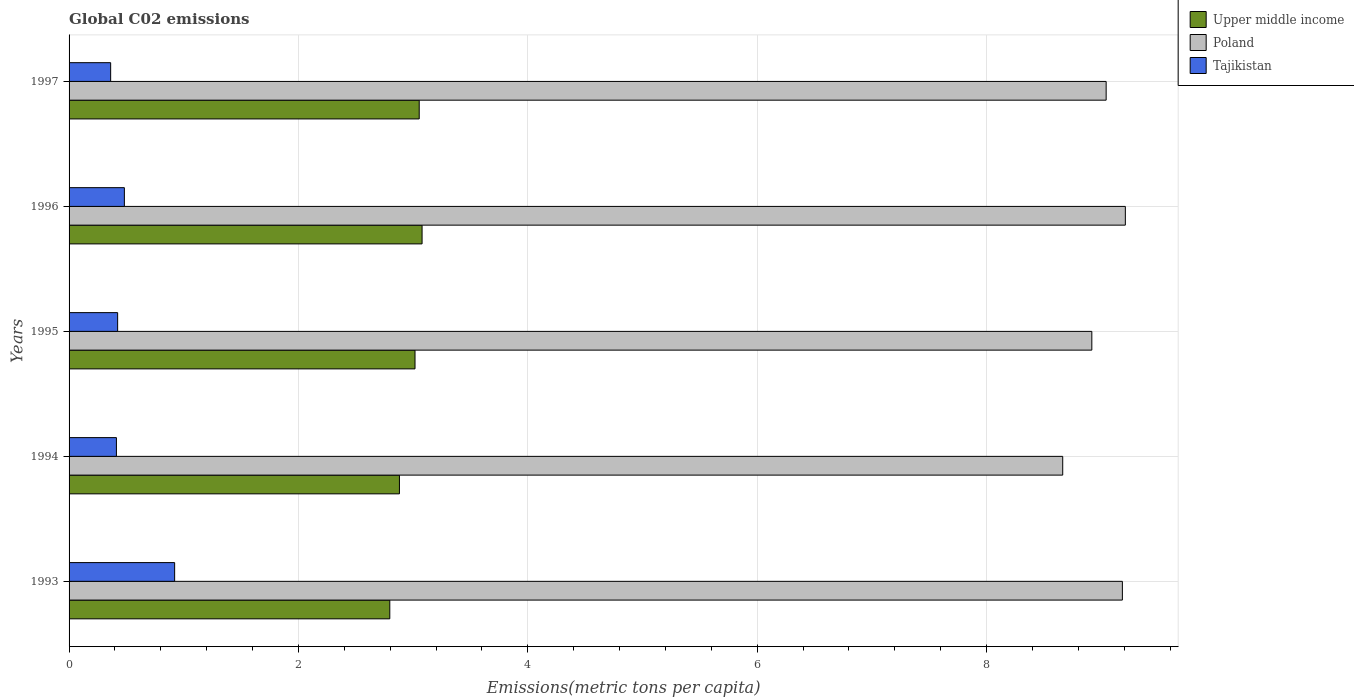How many different coloured bars are there?
Offer a very short reply. 3. Are the number of bars on each tick of the Y-axis equal?
Your response must be concise. Yes. How many bars are there on the 3rd tick from the top?
Your answer should be compact. 3. How many bars are there on the 4th tick from the bottom?
Offer a terse response. 3. In how many cases, is the number of bars for a given year not equal to the number of legend labels?
Your response must be concise. 0. What is the amount of CO2 emitted in in Poland in 1993?
Offer a terse response. 9.18. Across all years, what is the maximum amount of CO2 emitted in in Upper middle income?
Make the answer very short. 3.08. Across all years, what is the minimum amount of CO2 emitted in in Poland?
Offer a very short reply. 8.66. In which year was the amount of CO2 emitted in in Poland minimum?
Offer a very short reply. 1994. What is the total amount of CO2 emitted in in Poland in the graph?
Your answer should be compact. 45.02. What is the difference between the amount of CO2 emitted in in Tajikistan in 1993 and that in 1996?
Keep it short and to the point. 0.44. What is the difference between the amount of CO2 emitted in in Upper middle income in 1993 and the amount of CO2 emitted in in Tajikistan in 1994?
Ensure brevity in your answer.  2.38. What is the average amount of CO2 emitted in in Poland per year?
Keep it short and to the point. 9. In the year 1997, what is the difference between the amount of CO2 emitted in in Upper middle income and amount of CO2 emitted in in Tajikistan?
Provide a short and direct response. 2.69. What is the ratio of the amount of CO2 emitted in in Tajikistan in 1993 to that in 1994?
Provide a succinct answer. 2.23. Is the amount of CO2 emitted in in Poland in 1994 less than that in 1995?
Keep it short and to the point. Yes. Is the difference between the amount of CO2 emitted in in Upper middle income in 1995 and 1997 greater than the difference between the amount of CO2 emitted in in Tajikistan in 1995 and 1997?
Ensure brevity in your answer.  No. What is the difference between the highest and the second highest amount of CO2 emitted in in Upper middle income?
Provide a succinct answer. 0.03. What is the difference between the highest and the lowest amount of CO2 emitted in in Tajikistan?
Offer a terse response. 0.56. How many bars are there?
Provide a succinct answer. 15. What is the difference between two consecutive major ticks on the X-axis?
Keep it short and to the point. 2. Does the graph contain grids?
Keep it short and to the point. Yes. How are the legend labels stacked?
Your response must be concise. Vertical. What is the title of the graph?
Your answer should be compact. Global C02 emissions. Does "Eritrea" appear as one of the legend labels in the graph?
Provide a succinct answer. No. What is the label or title of the X-axis?
Give a very brief answer. Emissions(metric tons per capita). What is the Emissions(metric tons per capita) of Upper middle income in 1993?
Provide a short and direct response. 2.8. What is the Emissions(metric tons per capita) in Poland in 1993?
Offer a terse response. 9.18. What is the Emissions(metric tons per capita) in Tajikistan in 1993?
Ensure brevity in your answer.  0.92. What is the Emissions(metric tons per capita) of Upper middle income in 1994?
Provide a succinct answer. 2.88. What is the Emissions(metric tons per capita) of Poland in 1994?
Keep it short and to the point. 8.66. What is the Emissions(metric tons per capita) in Tajikistan in 1994?
Give a very brief answer. 0.41. What is the Emissions(metric tons per capita) in Upper middle income in 1995?
Your answer should be very brief. 3.02. What is the Emissions(metric tons per capita) of Poland in 1995?
Make the answer very short. 8.92. What is the Emissions(metric tons per capita) of Tajikistan in 1995?
Make the answer very short. 0.42. What is the Emissions(metric tons per capita) in Upper middle income in 1996?
Provide a succinct answer. 3.08. What is the Emissions(metric tons per capita) of Poland in 1996?
Offer a very short reply. 9.21. What is the Emissions(metric tons per capita) of Tajikistan in 1996?
Your answer should be compact. 0.48. What is the Emissions(metric tons per capita) of Upper middle income in 1997?
Provide a short and direct response. 3.05. What is the Emissions(metric tons per capita) in Poland in 1997?
Make the answer very short. 9.04. What is the Emissions(metric tons per capita) of Tajikistan in 1997?
Your answer should be compact. 0.36. Across all years, what is the maximum Emissions(metric tons per capita) of Upper middle income?
Keep it short and to the point. 3.08. Across all years, what is the maximum Emissions(metric tons per capita) in Poland?
Provide a succinct answer. 9.21. Across all years, what is the maximum Emissions(metric tons per capita) of Tajikistan?
Keep it short and to the point. 0.92. Across all years, what is the minimum Emissions(metric tons per capita) of Upper middle income?
Your answer should be compact. 2.8. Across all years, what is the minimum Emissions(metric tons per capita) of Poland?
Make the answer very short. 8.66. Across all years, what is the minimum Emissions(metric tons per capita) in Tajikistan?
Offer a very short reply. 0.36. What is the total Emissions(metric tons per capita) of Upper middle income in the graph?
Your response must be concise. 14.82. What is the total Emissions(metric tons per capita) of Poland in the graph?
Make the answer very short. 45.02. What is the total Emissions(metric tons per capita) in Tajikistan in the graph?
Provide a succinct answer. 2.6. What is the difference between the Emissions(metric tons per capita) of Upper middle income in 1993 and that in 1994?
Your response must be concise. -0.08. What is the difference between the Emissions(metric tons per capita) in Poland in 1993 and that in 1994?
Give a very brief answer. 0.52. What is the difference between the Emissions(metric tons per capita) in Tajikistan in 1993 and that in 1994?
Provide a succinct answer. 0.51. What is the difference between the Emissions(metric tons per capita) of Upper middle income in 1993 and that in 1995?
Offer a terse response. -0.22. What is the difference between the Emissions(metric tons per capita) of Poland in 1993 and that in 1995?
Provide a succinct answer. 0.27. What is the difference between the Emissions(metric tons per capita) of Tajikistan in 1993 and that in 1995?
Make the answer very short. 0.5. What is the difference between the Emissions(metric tons per capita) in Upper middle income in 1993 and that in 1996?
Keep it short and to the point. -0.28. What is the difference between the Emissions(metric tons per capita) of Poland in 1993 and that in 1996?
Make the answer very short. -0.03. What is the difference between the Emissions(metric tons per capita) in Tajikistan in 1993 and that in 1996?
Ensure brevity in your answer.  0.44. What is the difference between the Emissions(metric tons per capita) in Upper middle income in 1993 and that in 1997?
Provide a succinct answer. -0.26. What is the difference between the Emissions(metric tons per capita) in Poland in 1993 and that in 1997?
Offer a terse response. 0.14. What is the difference between the Emissions(metric tons per capita) of Tajikistan in 1993 and that in 1997?
Ensure brevity in your answer.  0.56. What is the difference between the Emissions(metric tons per capita) of Upper middle income in 1994 and that in 1995?
Make the answer very short. -0.14. What is the difference between the Emissions(metric tons per capita) in Poland in 1994 and that in 1995?
Keep it short and to the point. -0.25. What is the difference between the Emissions(metric tons per capita) of Tajikistan in 1994 and that in 1995?
Your response must be concise. -0.01. What is the difference between the Emissions(metric tons per capita) of Upper middle income in 1994 and that in 1996?
Provide a succinct answer. -0.2. What is the difference between the Emissions(metric tons per capita) in Poland in 1994 and that in 1996?
Provide a succinct answer. -0.55. What is the difference between the Emissions(metric tons per capita) of Tajikistan in 1994 and that in 1996?
Your answer should be very brief. -0.07. What is the difference between the Emissions(metric tons per capita) in Upper middle income in 1994 and that in 1997?
Keep it short and to the point. -0.17. What is the difference between the Emissions(metric tons per capita) in Poland in 1994 and that in 1997?
Give a very brief answer. -0.38. What is the difference between the Emissions(metric tons per capita) of Tajikistan in 1994 and that in 1997?
Make the answer very short. 0.05. What is the difference between the Emissions(metric tons per capita) in Upper middle income in 1995 and that in 1996?
Offer a very short reply. -0.06. What is the difference between the Emissions(metric tons per capita) in Poland in 1995 and that in 1996?
Your answer should be compact. -0.29. What is the difference between the Emissions(metric tons per capita) in Tajikistan in 1995 and that in 1996?
Your answer should be compact. -0.06. What is the difference between the Emissions(metric tons per capita) of Upper middle income in 1995 and that in 1997?
Your answer should be compact. -0.04. What is the difference between the Emissions(metric tons per capita) of Poland in 1995 and that in 1997?
Your answer should be compact. -0.12. What is the difference between the Emissions(metric tons per capita) in Tajikistan in 1995 and that in 1997?
Keep it short and to the point. 0.06. What is the difference between the Emissions(metric tons per capita) in Upper middle income in 1996 and that in 1997?
Ensure brevity in your answer.  0.03. What is the difference between the Emissions(metric tons per capita) in Poland in 1996 and that in 1997?
Give a very brief answer. 0.17. What is the difference between the Emissions(metric tons per capita) of Tajikistan in 1996 and that in 1997?
Your response must be concise. 0.12. What is the difference between the Emissions(metric tons per capita) in Upper middle income in 1993 and the Emissions(metric tons per capita) in Poland in 1994?
Keep it short and to the point. -5.87. What is the difference between the Emissions(metric tons per capita) in Upper middle income in 1993 and the Emissions(metric tons per capita) in Tajikistan in 1994?
Offer a terse response. 2.38. What is the difference between the Emissions(metric tons per capita) of Poland in 1993 and the Emissions(metric tons per capita) of Tajikistan in 1994?
Offer a terse response. 8.77. What is the difference between the Emissions(metric tons per capita) of Upper middle income in 1993 and the Emissions(metric tons per capita) of Poland in 1995?
Your answer should be very brief. -6.12. What is the difference between the Emissions(metric tons per capita) of Upper middle income in 1993 and the Emissions(metric tons per capita) of Tajikistan in 1995?
Offer a very short reply. 2.37. What is the difference between the Emissions(metric tons per capita) of Poland in 1993 and the Emissions(metric tons per capita) of Tajikistan in 1995?
Your response must be concise. 8.76. What is the difference between the Emissions(metric tons per capita) of Upper middle income in 1993 and the Emissions(metric tons per capita) of Poland in 1996?
Offer a very short reply. -6.41. What is the difference between the Emissions(metric tons per capita) of Upper middle income in 1993 and the Emissions(metric tons per capita) of Tajikistan in 1996?
Keep it short and to the point. 2.31. What is the difference between the Emissions(metric tons per capita) in Poland in 1993 and the Emissions(metric tons per capita) in Tajikistan in 1996?
Offer a terse response. 8.7. What is the difference between the Emissions(metric tons per capita) of Upper middle income in 1993 and the Emissions(metric tons per capita) of Poland in 1997?
Provide a short and direct response. -6.25. What is the difference between the Emissions(metric tons per capita) of Upper middle income in 1993 and the Emissions(metric tons per capita) of Tajikistan in 1997?
Give a very brief answer. 2.43. What is the difference between the Emissions(metric tons per capita) of Poland in 1993 and the Emissions(metric tons per capita) of Tajikistan in 1997?
Offer a terse response. 8.82. What is the difference between the Emissions(metric tons per capita) of Upper middle income in 1994 and the Emissions(metric tons per capita) of Poland in 1995?
Provide a succinct answer. -6.04. What is the difference between the Emissions(metric tons per capita) of Upper middle income in 1994 and the Emissions(metric tons per capita) of Tajikistan in 1995?
Offer a very short reply. 2.46. What is the difference between the Emissions(metric tons per capita) in Poland in 1994 and the Emissions(metric tons per capita) in Tajikistan in 1995?
Keep it short and to the point. 8.24. What is the difference between the Emissions(metric tons per capita) of Upper middle income in 1994 and the Emissions(metric tons per capita) of Poland in 1996?
Keep it short and to the point. -6.33. What is the difference between the Emissions(metric tons per capita) in Upper middle income in 1994 and the Emissions(metric tons per capita) in Tajikistan in 1996?
Make the answer very short. 2.4. What is the difference between the Emissions(metric tons per capita) in Poland in 1994 and the Emissions(metric tons per capita) in Tajikistan in 1996?
Ensure brevity in your answer.  8.18. What is the difference between the Emissions(metric tons per capita) in Upper middle income in 1994 and the Emissions(metric tons per capita) in Poland in 1997?
Ensure brevity in your answer.  -6.16. What is the difference between the Emissions(metric tons per capita) in Upper middle income in 1994 and the Emissions(metric tons per capita) in Tajikistan in 1997?
Your answer should be compact. 2.52. What is the difference between the Emissions(metric tons per capita) in Poland in 1994 and the Emissions(metric tons per capita) in Tajikistan in 1997?
Ensure brevity in your answer.  8.3. What is the difference between the Emissions(metric tons per capita) in Upper middle income in 1995 and the Emissions(metric tons per capita) in Poland in 1996?
Your answer should be compact. -6.19. What is the difference between the Emissions(metric tons per capita) of Upper middle income in 1995 and the Emissions(metric tons per capita) of Tajikistan in 1996?
Your response must be concise. 2.53. What is the difference between the Emissions(metric tons per capita) in Poland in 1995 and the Emissions(metric tons per capita) in Tajikistan in 1996?
Offer a very short reply. 8.44. What is the difference between the Emissions(metric tons per capita) in Upper middle income in 1995 and the Emissions(metric tons per capita) in Poland in 1997?
Keep it short and to the point. -6.03. What is the difference between the Emissions(metric tons per capita) in Upper middle income in 1995 and the Emissions(metric tons per capita) in Tajikistan in 1997?
Your answer should be very brief. 2.65. What is the difference between the Emissions(metric tons per capita) of Poland in 1995 and the Emissions(metric tons per capita) of Tajikistan in 1997?
Offer a terse response. 8.56. What is the difference between the Emissions(metric tons per capita) of Upper middle income in 1996 and the Emissions(metric tons per capita) of Poland in 1997?
Ensure brevity in your answer.  -5.96. What is the difference between the Emissions(metric tons per capita) in Upper middle income in 1996 and the Emissions(metric tons per capita) in Tajikistan in 1997?
Provide a short and direct response. 2.72. What is the difference between the Emissions(metric tons per capita) in Poland in 1996 and the Emissions(metric tons per capita) in Tajikistan in 1997?
Offer a terse response. 8.85. What is the average Emissions(metric tons per capita) in Upper middle income per year?
Offer a terse response. 2.96. What is the average Emissions(metric tons per capita) of Poland per year?
Keep it short and to the point. 9. What is the average Emissions(metric tons per capita) in Tajikistan per year?
Provide a succinct answer. 0.52. In the year 1993, what is the difference between the Emissions(metric tons per capita) of Upper middle income and Emissions(metric tons per capita) of Poland?
Offer a terse response. -6.39. In the year 1993, what is the difference between the Emissions(metric tons per capita) in Upper middle income and Emissions(metric tons per capita) in Tajikistan?
Offer a terse response. 1.88. In the year 1993, what is the difference between the Emissions(metric tons per capita) in Poland and Emissions(metric tons per capita) in Tajikistan?
Your answer should be compact. 8.26. In the year 1994, what is the difference between the Emissions(metric tons per capita) of Upper middle income and Emissions(metric tons per capita) of Poland?
Offer a very short reply. -5.78. In the year 1994, what is the difference between the Emissions(metric tons per capita) of Upper middle income and Emissions(metric tons per capita) of Tajikistan?
Give a very brief answer. 2.47. In the year 1994, what is the difference between the Emissions(metric tons per capita) in Poland and Emissions(metric tons per capita) in Tajikistan?
Your answer should be compact. 8.25. In the year 1995, what is the difference between the Emissions(metric tons per capita) of Upper middle income and Emissions(metric tons per capita) of Poland?
Provide a succinct answer. -5.9. In the year 1995, what is the difference between the Emissions(metric tons per capita) of Upper middle income and Emissions(metric tons per capita) of Tajikistan?
Offer a very short reply. 2.59. In the year 1995, what is the difference between the Emissions(metric tons per capita) in Poland and Emissions(metric tons per capita) in Tajikistan?
Your response must be concise. 8.49. In the year 1996, what is the difference between the Emissions(metric tons per capita) of Upper middle income and Emissions(metric tons per capita) of Poland?
Your answer should be very brief. -6.13. In the year 1996, what is the difference between the Emissions(metric tons per capita) of Upper middle income and Emissions(metric tons per capita) of Tajikistan?
Make the answer very short. 2.6. In the year 1996, what is the difference between the Emissions(metric tons per capita) of Poland and Emissions(metric tons per capita) of Tajikistan?
Offer a very short reply. 8.73. In the year 1997, what is the difference between the Emissions(metric tons per capita) of Upper middle income and Emissions(metric tons per capita) of Poland?
Make the answer very short. -5.99. In the year 1997, what is the difference between the Emissions(metric tons per capita) of Upper middle income and Emissions(metric tons per capita) of Tajikistan?
Offer a terse response. 2.69. In the year 1997, what is the difference between the Emissions(metric tons per capita) in Poland and Emissions(metric tons per capita) in Tajikistan?
Make the answer very short. 8.68. What is the ratio of the Emissions(metric tons per capita) in Upper middle income in 1993 to that in 1994?
Your response must be concise. 0.97. What is the ratio of the Emissions(metric tons per capita) of Poland in 1993 to that in 1994?
Make the answer very short. 1.06. What is the ratio of the Emissions(metric tons per capita) in Tajikistan in 1993 to that in 1994?
Provide a succinct answer. 2.23. What is the ratio of the Emissions(metric tons per capita) in Upper middle income in 1993 to that in 1995?
Provide a short and direct response. 0.93. What is the ratio of the Emissions(metric tons per capita) in Poland in 1993 to that in 1995?
Ensure brevity in your answer.  1.03. What is the ratio of the Emissions(metric tons per capita) of Tajikistan in 1993 to that in 1995?
Your answer should be very brief. 2.17. What is the ratio of the Emissions(metric tons per capita) of Upper middle income in 1993 to that in 1996?
Offer a terse response. 0.91. What is the ratio of the Emissions(metric tons per capita) of Poland in 1993 to that in 1996?
Make the answer very short. 1. What is the ratio of the Emissions(metric tons per capita) of Tajikistan in 1993 to that in 1996?
Your answer should be very brief. 1.91. What is the ratio of the Emissions(metric tons per capita) in Upper middle income in 1993 to that in 1997?
Your response must be concise. 0.92. What is the ratio of the Emissions(metric tons per capita) of Poland in 1993 to that in 1997?
Your answer should be compact. 1.02. What is the ratio of the Emissions(metric tons per capita) of Tajikistan in 1993 to that in 1997?
Give a very brief answer. 2.54. What is the ratio of the Emissions(metric tons per capita) in Upper middle income in 1994 to that in 1995?
Offer a terse response. 0.95. What is the ratio of the Emissions(metric tons per capita) of Poland in 1994 to that in 1995?
Provide a short and direct response. 0.97. What is the ratio of the Emissions(metric tons per capita) of Tajikistan in 1994 to that in 1995?
Offer a very short reply. 0.97. What is the ratio of the Emissions(metric tons per capita) in Upper middle income in 1994 to that in 1996?
Ensure brevity in your answer.  0.94. What is the ratio of the Emissions(metric tons per capita) of Poland in 1994 to that in 1996?
Your answer should be compact. 0.94. What is the ratio of the Emissions(metric tons per capita) in Tajikistan in 1994 to that in 1996?
Offer a very short reply. 0.86. What is the ratio of the Emissions(metric tons per capita) in Upper middle income in 1994 to that in 1997?
Ensure brevity in your answer.  0.94. What is the ratio of the Emissions(metric tons per capita) in Poland in 1994 to that in 1997?
Your answer should be very brief. 0.96. What is the ratio of the Emissions(metric tons per capita) of Tajikistan in 1994 to that in 1997?
Your answer should be compact. 1.14. What is the ratio of the Emissions(metric tons per capita) in Upper middle income in 1995 to that in 1996?
Provide a succinct answer. 0.98. What is the ratio of the Emissions(metric tons per capita) in Poland in 1995 to that in 1996?
Provide a succinct answer. 0.97. What is the ratio of the Emissions(metric tons per capita) of Tajikistan in 1995 to that in 1996?
Give a very brief answer. 0.88. What is the ratio of the Emissions(metric tons per capita) in Upper middle income in 1995 to that in 1997?
Your answer should be very brief. 0.99. What is the ratio of the Emissions(metric tons per capita) in Poland in 1995 to that in 1997?
Provide a short and direct response. 0.99. What is the ratio of the Emissions(metric tons per capita) of Tajikistan in 1995 to that in 1997?
Ensure brevity in your answer.  1.17. What is the ratio of the Emissions(metric tons per capita) in Upper middle income in 1996 to that in 1997?
Your answer should be compact. 1.01. What is the ratio of the Emissions(metric tons per capita) of Poland in 1996 to that in 1997?
Offer a very short reply. 1.02. What is the ratio of the Emissions(metric tons per capita) in Tajikistan in 1996 to that in 1997?
Your answer should be very brief. 1.33. What is the difference between the highest and the second highest Emissions(metric tons per capita) in Upper middle income?
Offer a terse response. 0.03. What is the difference between the highest and the second highest Emissions(metric tons per capita) of Poland?
Make the answer very short. 0.03. What is the difference between the highest and the second highest Emissions(metric tons per capita) of Tajikistan?
Your answer should be compact. 0.44. What is the difference between the highest and the lowest Emissions(metric tons per capita) of Upper middle income?
Give a very brief answer. 0.28. What is the difference between the highest and the lowest Emissions(metric tons per capita) of Poland?
Ensure brevity in your answer.  0.55. What is the difference between the highest and the lowest Emissions(metric tons per capita) of Tajikistan?
Your response must be concise. 0.56. 